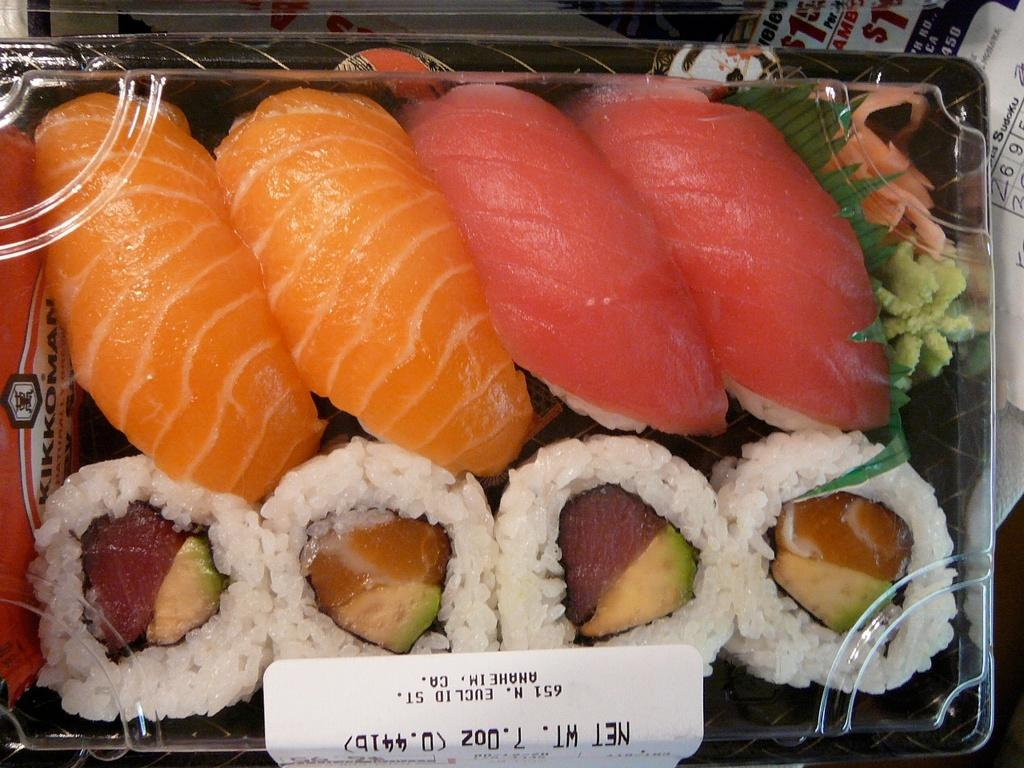What is the main object in the image? There is a container in the image. What is inside the container? Food items are present in the container. What type of hat is the container wearing in the image? There is no hat present in the image, as the main object is a container and not a person or animate object. 